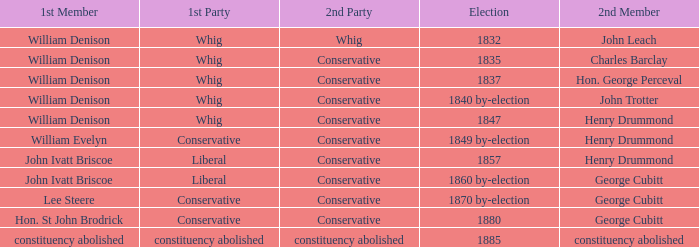Which party's 1st member is John Ivatt Briscoe in an election in 1857? Liberal. 